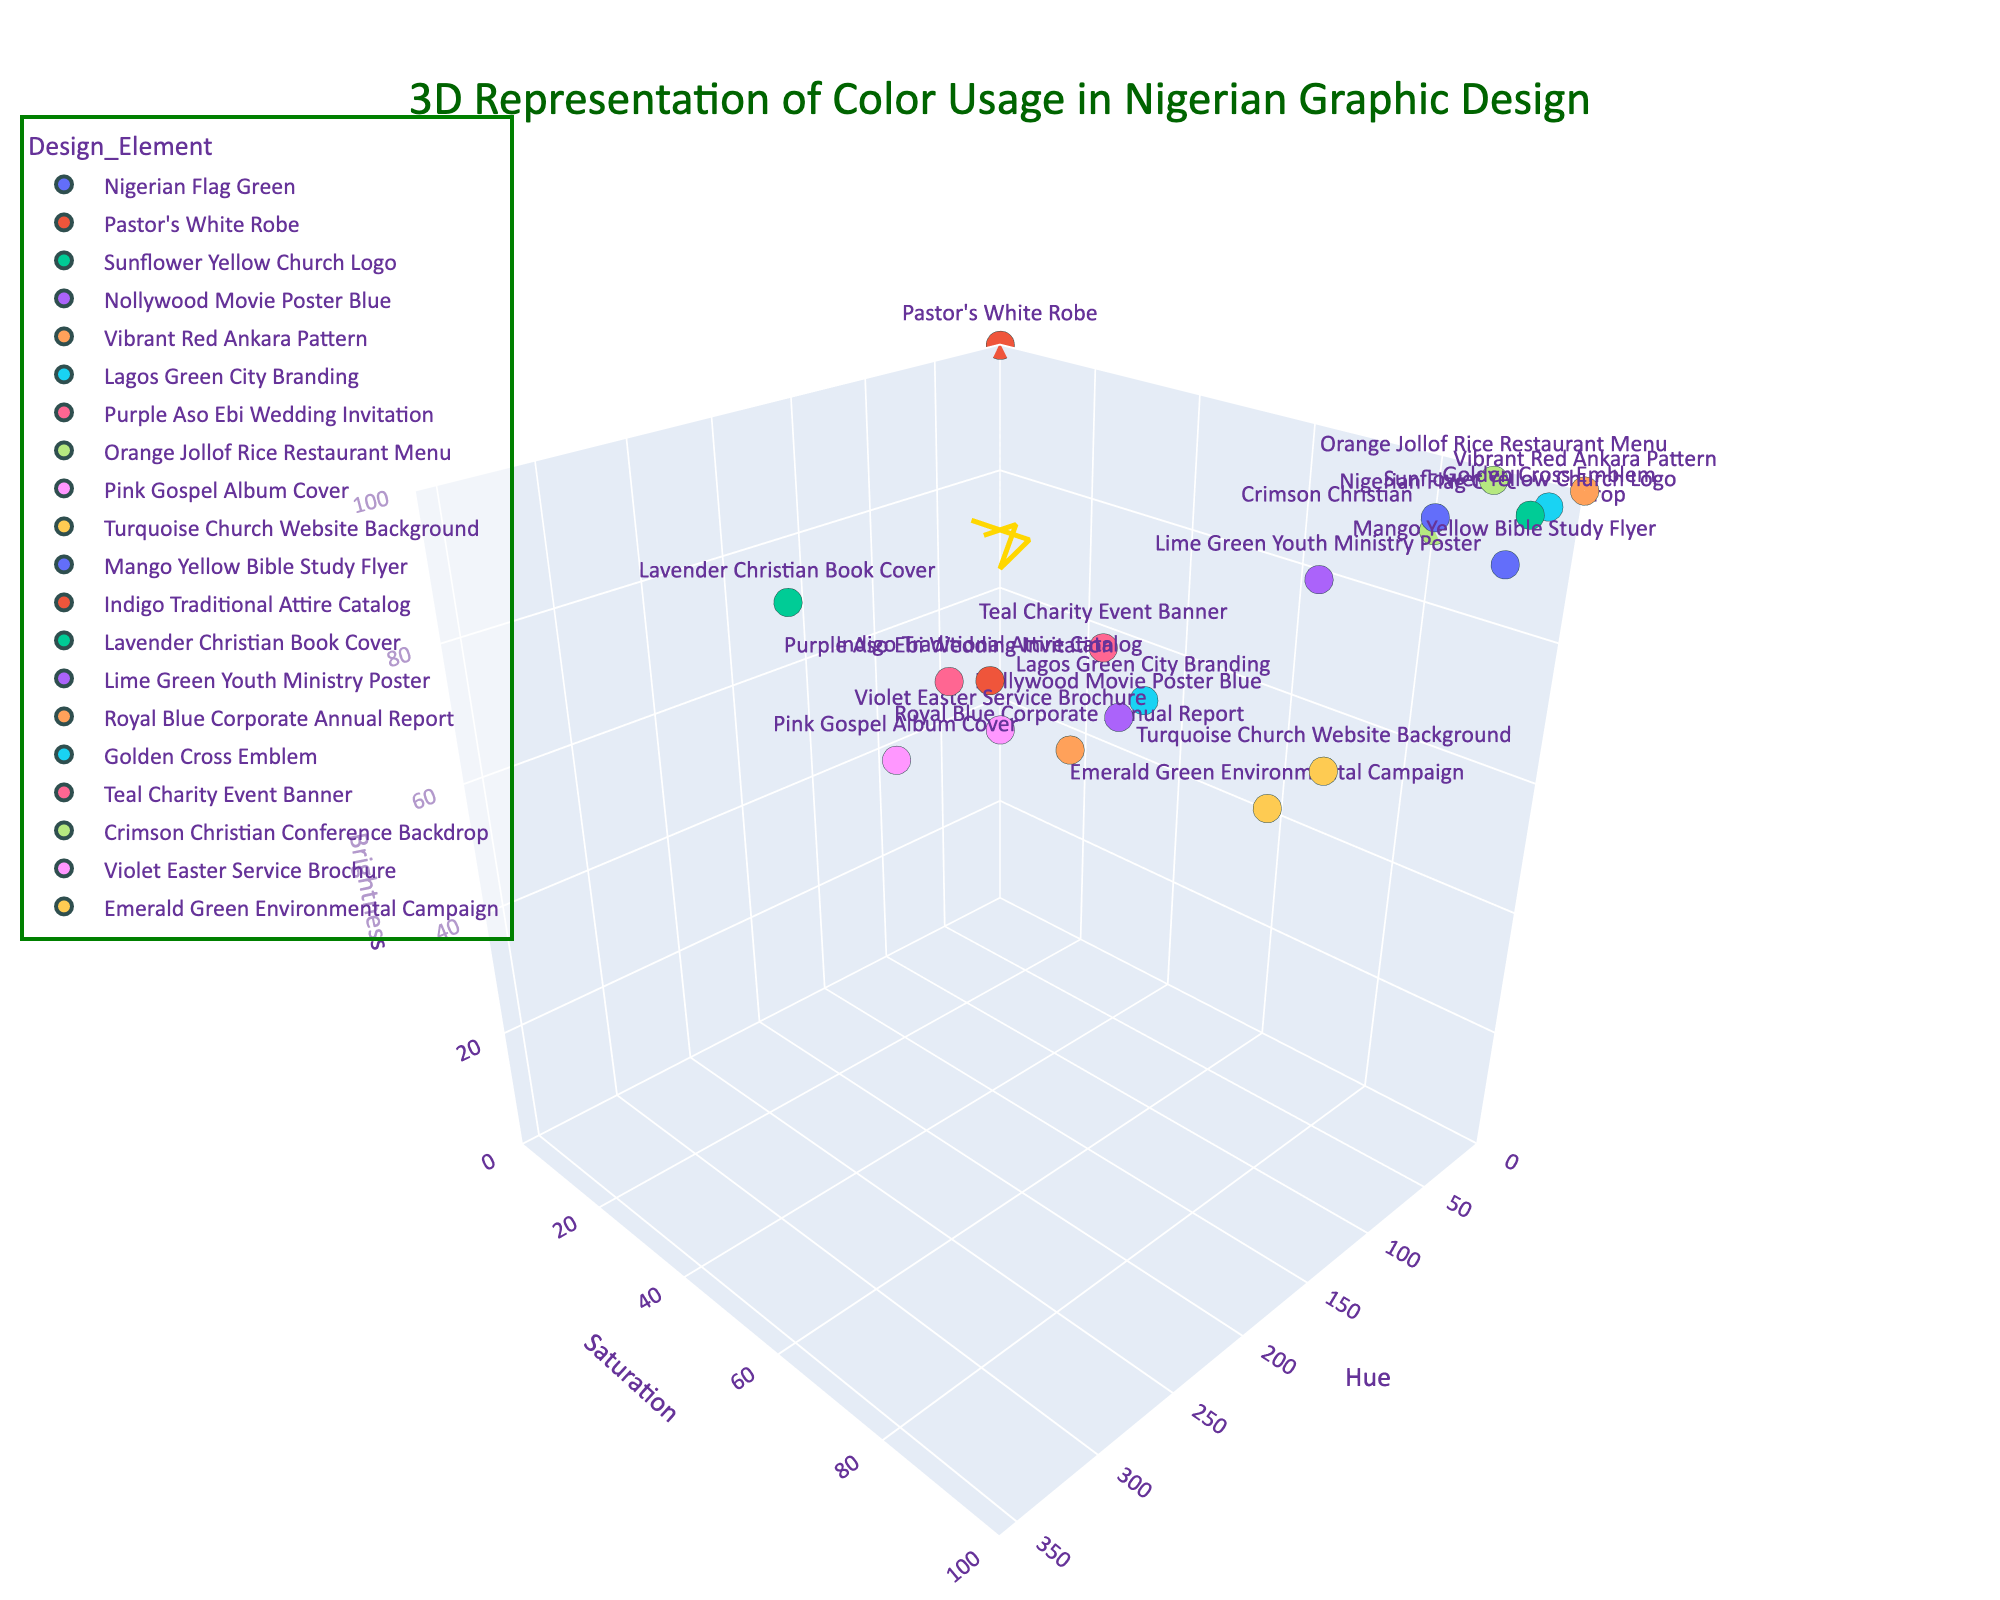What is the title of the 3D plot? The title of the figure is displayed at the top and should give an overview of the visualized data.
Answer: 3D Representation of Color Usage in Nigerian Graphic Design How many data points represent colors used in Nigerian graphic design trends in the plot? Count the distinct data points plotted in the 3D space based on the given dataset. Each data point represents a unique design element with specific hue, saturation, and brightness values.
Answer: 20 Which design element has the highest saturation value? Find the design element with the highest Y-axis value since saturation is plotted on the Y-axis. The highest value is 100.
Answer: Golden Cross Emblem, Sunflower Yellow Church Logo, Vibrant Red Ankara Pattern, Mango Yellow Bible Study Flyer, and Turquoise Church Website Background What is the average brightness value for the design elements with hue values less than 50? Identify the data points where the hue value is less than 50. Extract their brightness values and calculate their average.
Answer: 96.2 Which design element corresponds to the Nigeran Flag Green, and what are its hue, saturation, and brightness values? Look for the design element labeled "Nigerian Flag Green" in the plot, then read off its respective hue, saturation, and brightness values.
Answer: Hue: 30, Saturation: 85, Brightness: 95 What is the difference in brightness between the Vibrant Red Ankara Pattern and the Royal Blue Corporate Annual Report? Identify the brightness values for both design elements and subtract the brightness of the Royal Blue Corporate Annual Report from that of the Vibrant Red Ankara Pattern.
Answer: 25 (100 - 75) Which design elements fall within the hue range of 300 to 360? Locate and list the design elements that have hue values within the specified range.
Answer: Lavender Christian Book Cover, Pink Gospel Album Cover For design elements with saturation values greater than 90, what are their corresponding hues? Identify the data points with saturation values above 90 and note their corresponding hue values.
Answer: Hue: 45, 60, 15 (for Sunflower Yellow Church Logo, Mango Yellow Bible Study Flyer, Orange Jollof Rice Restaurant Menu) Is there any design element that has a hue value of exactly 90? If yes, what is it? Look for the data point where the hue value is 90 and determine the associated design element.
Answer: Lime Green Youth Ministry Poster Compare the brightness of the Lagos Green City Branding and the Nollywood Movie Poster Blue. Which one is brighter? Identify the brightness values for both design elements and compare them to determine which one is higher.
Answer: Lagos Green City Branding 